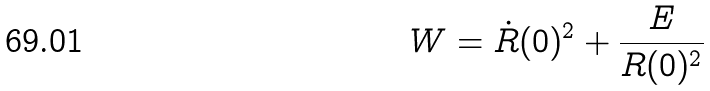Convert formula to latex. <formula><loc_0><loc_0><loc_500><loc_500>W = \dot { R } ( 0 ) ^ { 2 } + \frac { E } { R ( 0 ) ^ { 2 } }</formula> 